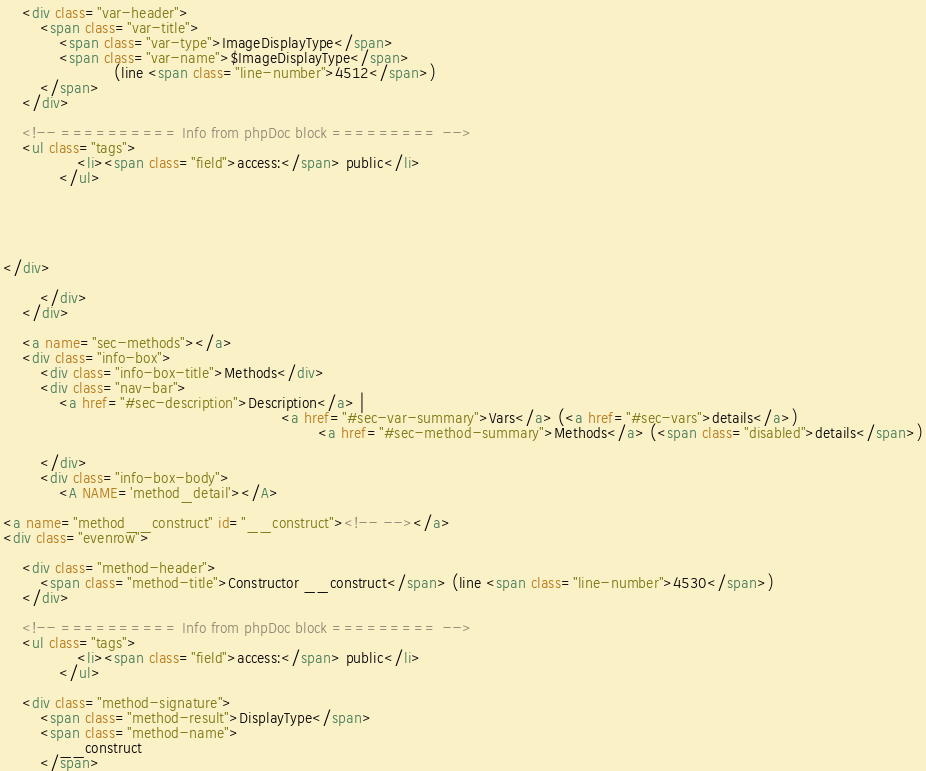<code> <loc_0><loc_0><loc_500><loc_500><_HTML_>	<div class="var-header">
		<span class="var-title">
			<span class="var-type">ImageDisplayType</span>
			<span class="var-name">$ImageDisplayType</span>
						(line <span class="line-number">4512</span>)
		</span>
	</div>

	<!-- ========== Info from phpDoc block ========= -->
	<ul class="tags">
				<li><span class="field">access:</span> public</li>
			</ul>
	
	
		
		

</div>
						
		</div>
	</div>
	
	<a name="sec-methods"></a>
	<div class="info-box">
		<div class="info-box-title">Methods</div>
		<div class="nav-bar">
			<a href="#sec-description">Description</a> |
															<a href="#sec-var-summary">Vars</a> (<a href="#sec-vars">details</a>)
																	<a href="#sec-method-summary">Methods</a> (<span class="disabled">details</span>)
						
		</div>
		<div class="info-box-body">
			<A NAME='method_detail'></A>

<a name="method__construct" id="__construct"><!-- --></a>
<div class="evenrow">
	
	<div class="method-header">
		<span class="method-title">Constructor __construct</span> (line <span class="line-number">4530</span>)
	</div> 
	
	<!-- ========== Info from phpDoc block ========= -->
	<ul class="tags">
				<li><span class="field">access:</span> public</li>
			</ul>
	
	<div class="method-signature">
		<span class="method-result">DisplayType</span>
		<span class="method-name">
			__construct
		</span></code> 